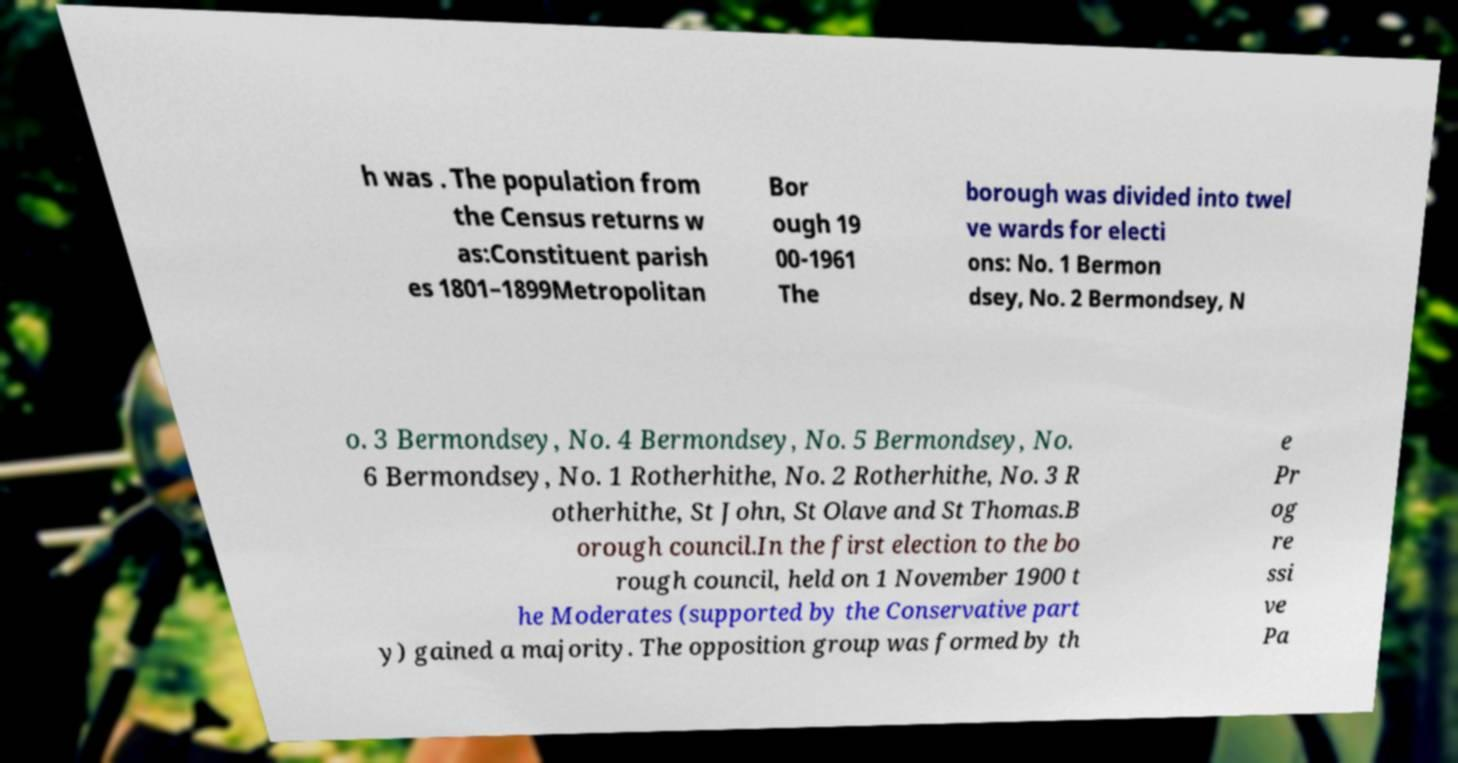Please identify and transcribe the text found in this image. h was . The population from the Census returns w as:Constituent parish es 1801–1899Metropolitan Bor ough 19 00-1961 The borough was divided into twel ve wards for electi ons: No. 1 Bermon dsey, No. 2 Bermondsey, N o. 3 Bermondsey, No. 4 Bermondsey, No. 5 Bermondsey, No. 6 Bermondsey, No. 1 Rotherhithe, No. 2 Rotherhithe, No. 3 R otherhithe, St John, St Olave and St Thomas.B orough council.In the first election to the bo rough council, held on 1 November 1900 t he Moderates (supported by the Conservative part y) gained a majority. The opposition group was formed by th e Pr og re ssi ve Pa 